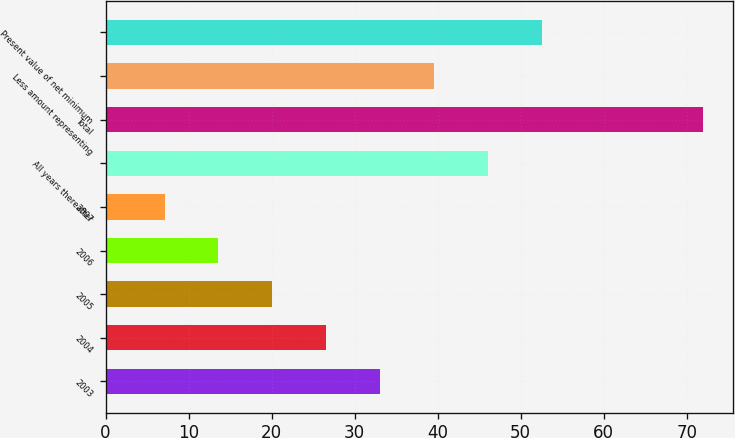Convert chart. <chart><loc_0><loc_0><loc_500><loc_500><bar_chart><fcel>2003<fcel>2004<fcel>2005<fcel>2006<fcel>2007<fcel>All years thereafter<fcel>Total<fcel>Less amount representing<fcel>Present value of net minimum<nl><fcel>33.06<fcel>26.57<fcel>20.08<fcel>13.59<fcel>7.1<fcel>46.04<fcel>72<fcel>39.55<fcel>52.53<nl></chart> 